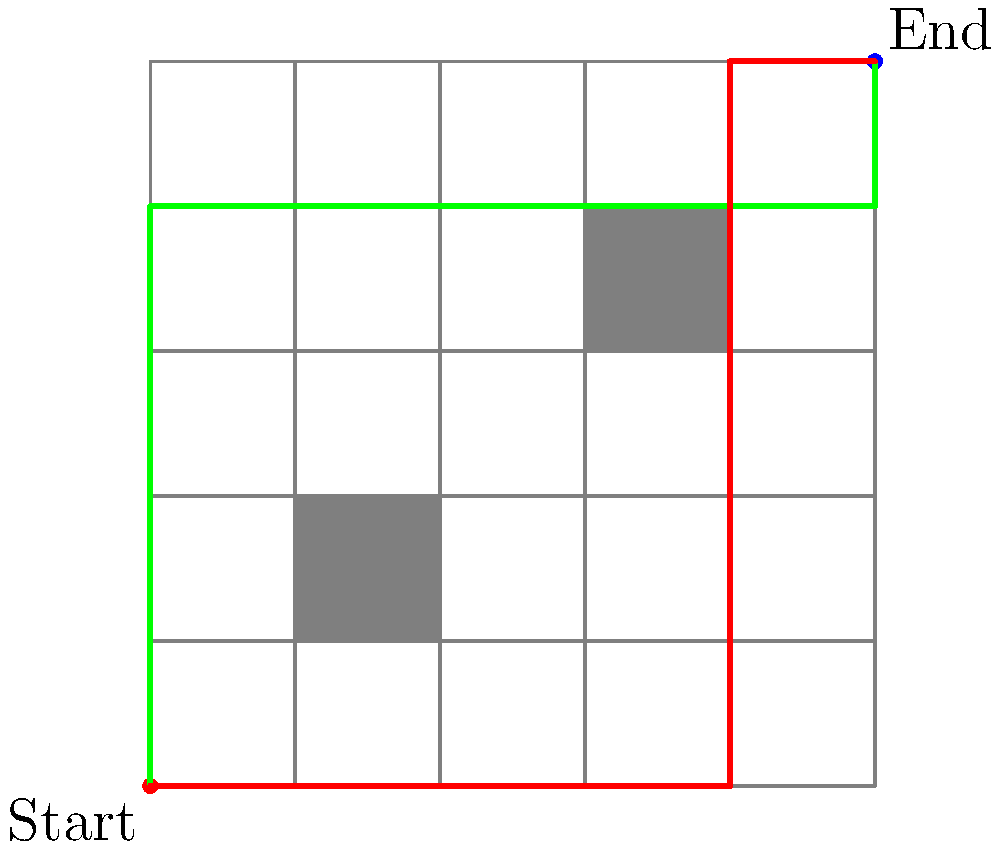In a warehouse represented by a 5x5 grid, an autonomous robot needs to navigate from the start point (0,0) to the end point (5,5). Two obstacles are present at coordinates (1,1) to (2,2) and (3,3) to (4,4). Two potential paths are shown: a green path and a red path. Which path is more efficient for the robot to take, and by how many grid units? Assume the robot can only move horizontally or vertically. To solve this problem, we need to calculate the length of each path and compare them:

1. Green path:
   - Move up: 4 units
   - Move right: 5 units
   - Move up: 1 unit
   Total length = 4 + 5 + 1 = 10 units

2. Red path:
   - Move right: 4 units
   - Move up: 5 units
   - Move right: 1 unit
   Total length = 4 + 5 + 1 = 10 units

Both paths have the same length of 10 units. However, we need to consider the efficiency in terms of time and energy consumption:

1. The green path requires two changes in direction (up, right, up).
2. The red path requires only one change in direction (right, up, right).

In robotics, changing direction often requires more time and energy than moving in a straight line. Each change in direction may involve deceleration, rotation, and acceleration, which consumes more resources.

Therefore, the red path is more efficient as it minimizes the number of direction changes, even though both paths have the same length in grid units.

The difference in efficiency cannot be measured in grid units, as both paths have the same length. The efficiency gain comes from reduced energy consumption and time saved during direction changes.
Answer: Red path; 0 grid units difference but more efficient due to fewer direction changes. 